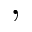<formula> <loc_0><loc_0><loc_500><loc_500>,</formula> 